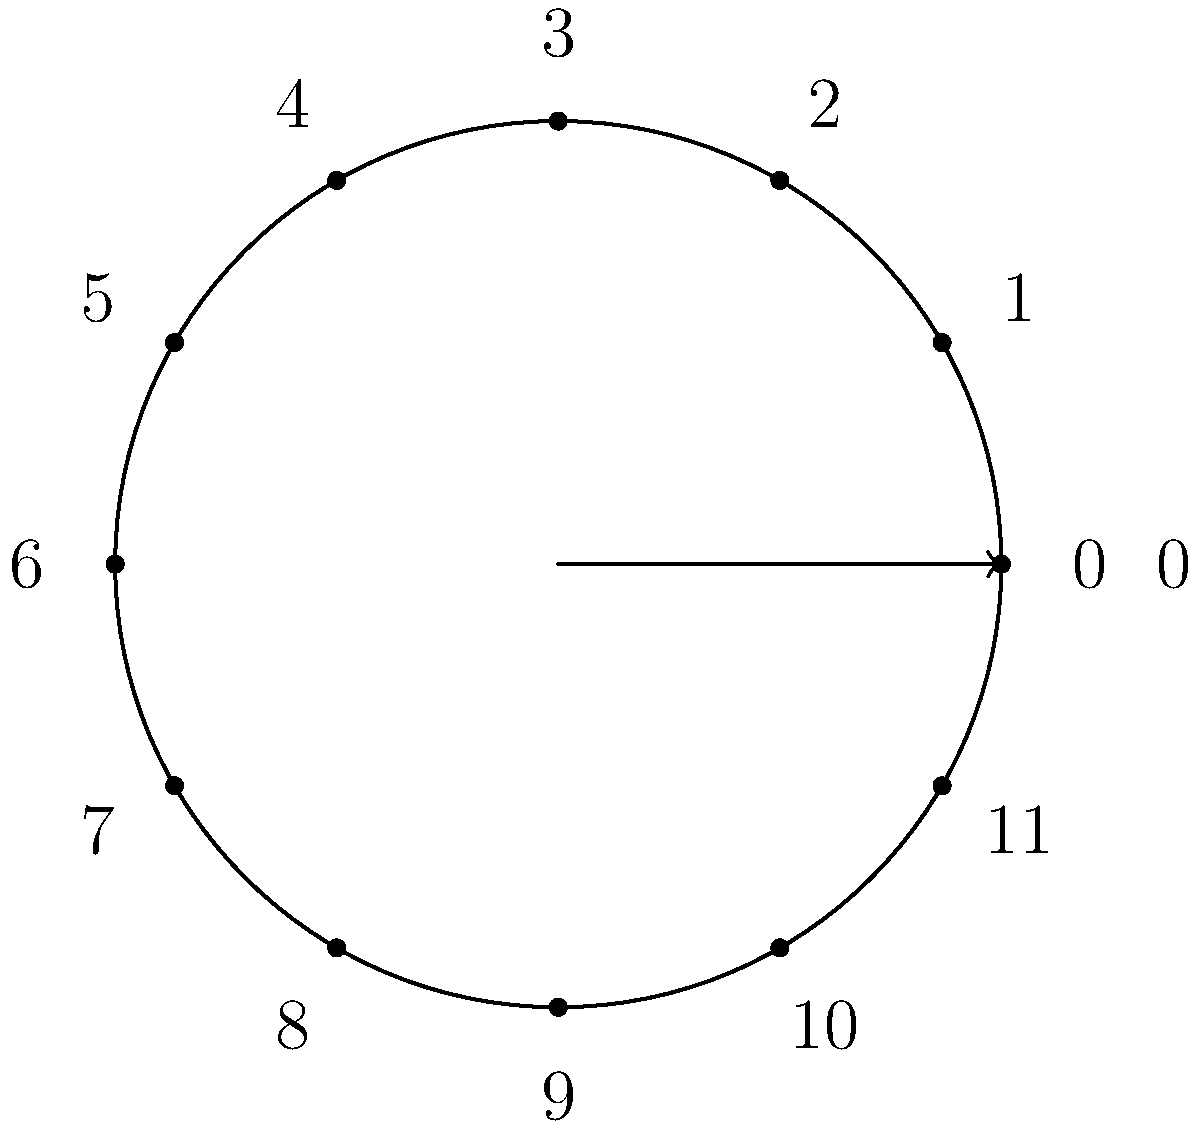You're tuning your radio for the perfect frequency to broadcast your pun-tastic show. The dial has 12 discrete settings, numbered 0 to 11. If you keep turning the dial clockwise, it wraps around from 11 back to 0. What is the order of the cyclic group formed by this radio dial, and how many unique generators does this group have? Let's break this down step-by-step:

1) The radio dial forms a cyclic group because:
   - It has a finite number of elements (12 settings)
   - Rotating the dial is associative
   - There's an identity element (0, or no rotation)
   - Each rotation has an inverse (rotating back)
   - Any rotation can be achieved by repeated application of a single rotation

2) The order of a cyclic group is the number of elements in the group. Here, we have 12 settings, so the order is 12.

3) To find the number of generators, we need to count the elements that, when repeatedly applied, generate all elements of the group.

4) In a cyclic group of order $n$, the number of generators is equal to $\phi(n)$, where $\phi$ is Euler's totient function.

5) $\phi(12)$ counts the numbers from 1 to 12 that are coprime to 12.

6) The numbers coprime to 12 are 1, 5, 7, and 11.

7) Therefore, $\phi(12) = 4$.

So, the group has 4 generators: rotating by 1, 5, 7, or 11 positions will eventually generate all elements of the group.
Answer: Order: 12, Generators: 4 